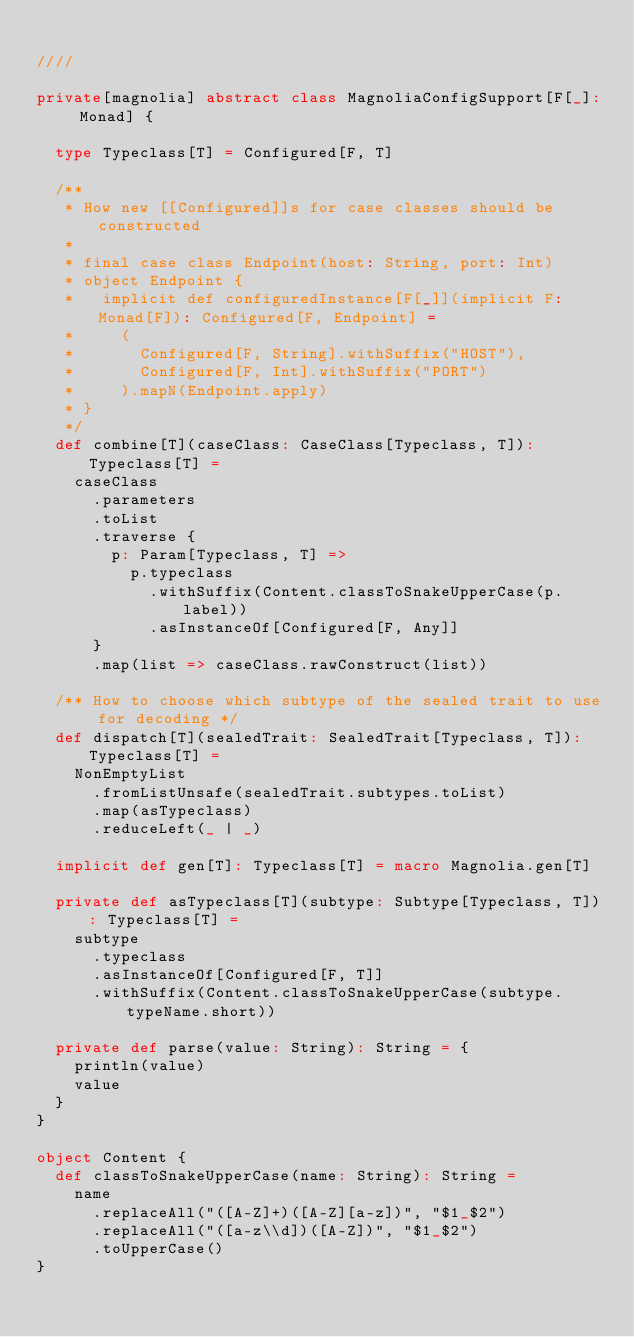<code> <loc_0><loc_0><loc_500><loc_500><_Scala_>
////

private[magnolia] abstract class MagnoliaConfigSupport[F[_]: Monad] {

  type Typeclass[T] = Configured[F, T]

  /**
   * How new [[Configured]]s for case classes should be constructed
   *
   * final case class Endpoint(host: String, port: Int)
   * object Endpoint {
   *   implicit def configuredInstance[F[_]](implicit F: Monad[F]): Configured[F, Endpoint] =
   *     (
   *       Configured[F, String].withSuffix("HOST"),
   *       Configured[F, Int].withSuffix("PORT")
   *     ).mapN(Endpoint.apply)
   * }
   */
  def combine[T](caseClass: CaseClass[Typeclass, T]): Typeclass[T] =
    caseClass
      .parameters
      .toList
      .traverse {
        p: Param[Typeclass, T] =>
          p.typeclass
            .withSuffix(Content.classToSnakeUpperCase(p.label))
            .asInstanceOf[Configured[F, Any]]
      }
      .map(list => caseClass.rawConstruct(list))

  /** How to choose which subtype of the sealed trait to use for decoding */
  def dispatch[T](sealedTrait: SealedTrait[Typeclass, T]): Typeclass[T] =
    NonEmptyList
      .fromListUnsafe(sealedTrait.subtypes.toList)
      .map(asTypeclass)
      .reduceLeft(_ | _)

  implicit def gen[T]: Typeclass[T] = macro Magnolia.gen[T]

  private def asTypeclass[T](subtype: Subtype[Typeclass, T]): Typeclass[T] =
    subtype
      .typeclass
      .asInstanceOf[Configured[F, T]]
      .withSuffix(Content.classToSnakeUpperCase(subtype.typeName.short))

  private def parse(value: String): String = {
    println(value)
    value
  }
}

object Content {
  def classToSnakeUpperCase(name: String): String =
    name
      .replaceAll("([A-Z]+)([A-Z][a-z])", "$1_$2")
      .replaceAll("([a-z\\d])([A-Z])", "$1_$2")
      .toUpperCase()
}
</code> 